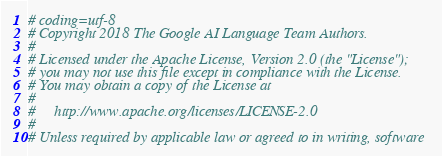<code> <loc_0><loc_0><loc_500><loc_500><_Python_># coding=utf-8
# Copyright 2018 The Google AI Language Team Authors.
#
# Licensed under the Apache License, Version 2.0 (the "License");
# you may not use this file except in compliance with the License.
# You may obtain a copy of the License at
#
#     http://www.apache.org/licenses/LICENSE-2.0
#
# Unless required by applicable law or agreed to in writing, software</code> 